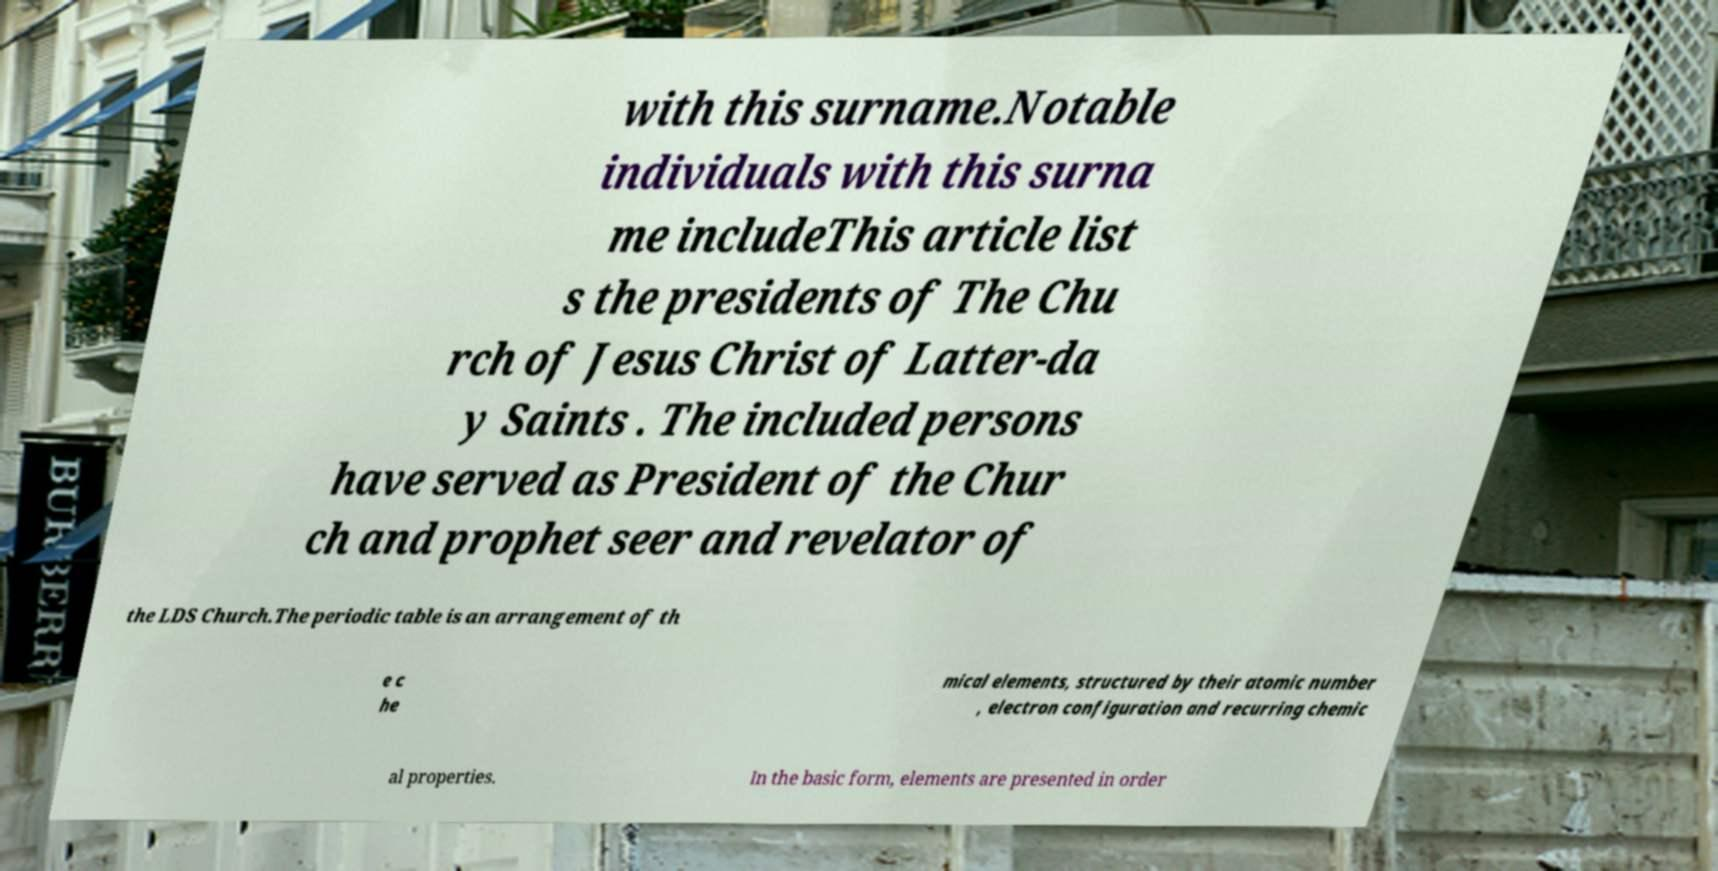Could you assist in decoding the text presented in this image and type it out clearly? with this surname.Notable individuals with this surna me includeThis article list s the presidents of The Chu rch of Jesus Christ of Latter-da y Saints . The included persons have served as President of the Chur ch and prophet seer and revelator of the LDS Church.The periodic table is an arrangement of th e c he mical elements, structured by their atomic number , electron configuration and recurring chemic al properties. In the basic form, elements are presented in order 